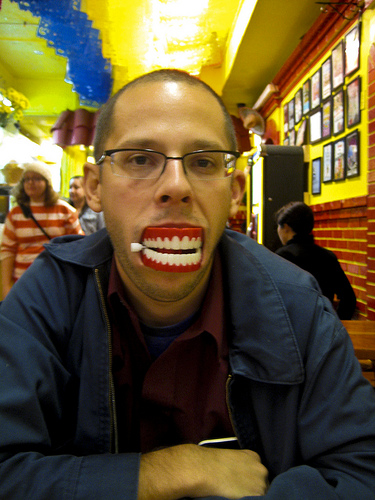<image>
Is there a person behind the table? No. The person is not behind the table. From this viewpoint, the person appears to be positioned elsewhere in the scene. Is the teeth on the man? No. The teeth is not positioned on the man. They may be near each other, but the teeth is not supported by or resting on top of the man. 